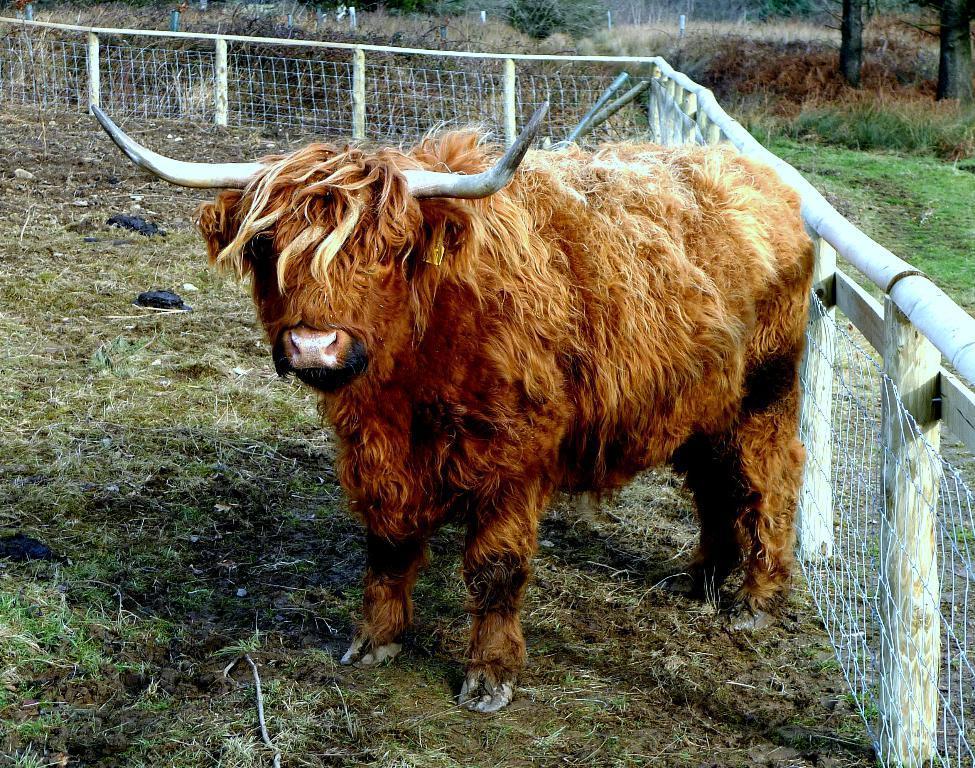In one or two sentences, can you explain what this image depicts? In this picture there is a yak in the center of the image and there is a boundary in front of it, there is grass land around the area of the image. 